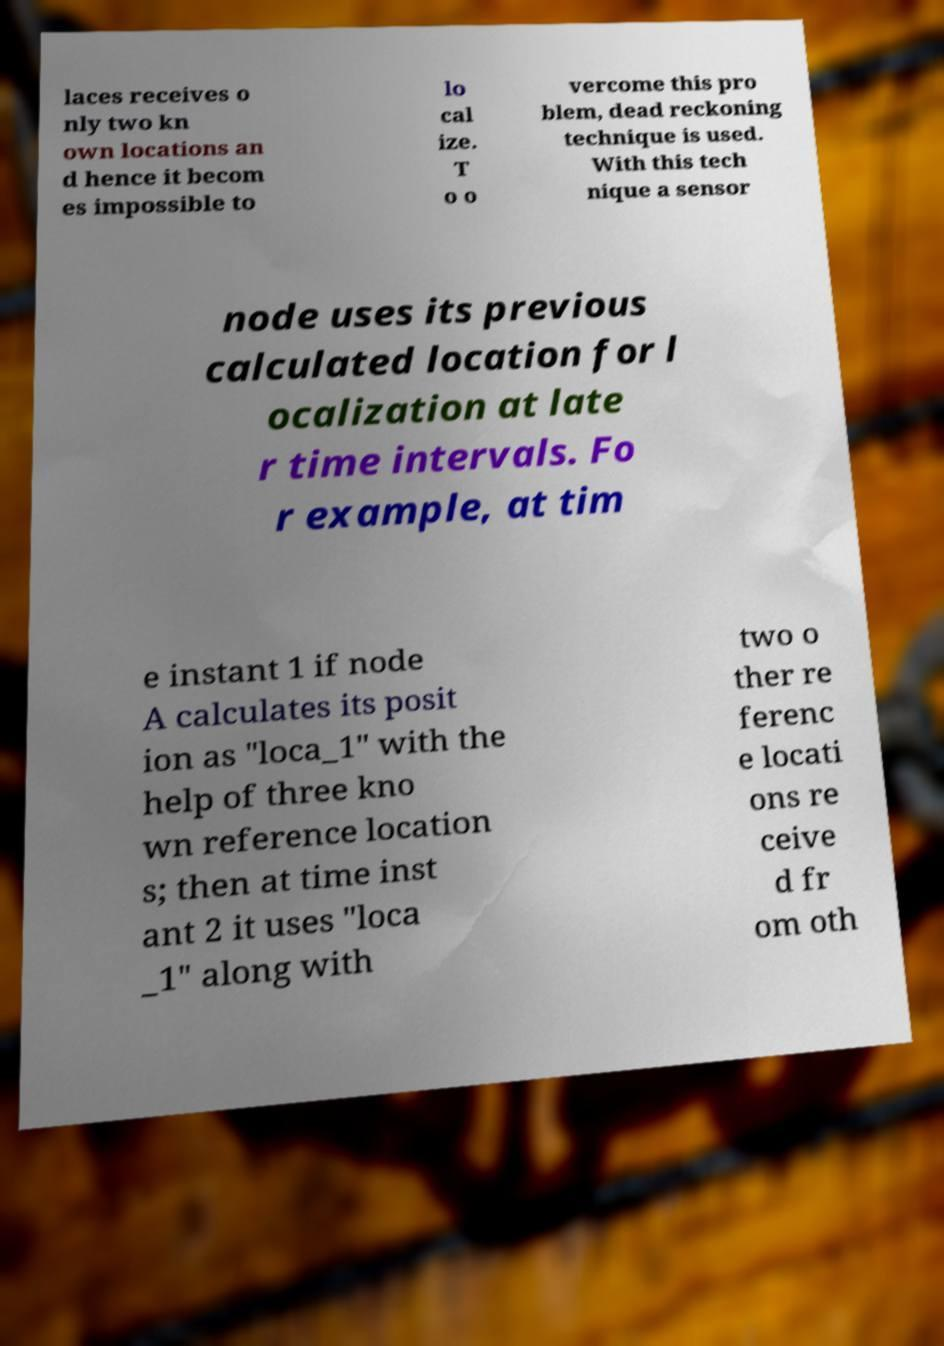Please read and relay the text visible in this image. What does it say? laces receives o nly two kn own locations an d hence it becom es impossible to lo cal ize. T o o vercome this pro blem, dead reckoning technique is used. With this tech nique a sensor node uses its previous calculated location for l ocalization at late r time intervals. Fo r example, at tim e instant 1 if node A calculates its posit ion as "loca_1" with the help of three kno wn reference location s; then at time inst ant 2 it uses "loca _1" along with two o ther re ferenc e locati ons re ceive d fr om oth 